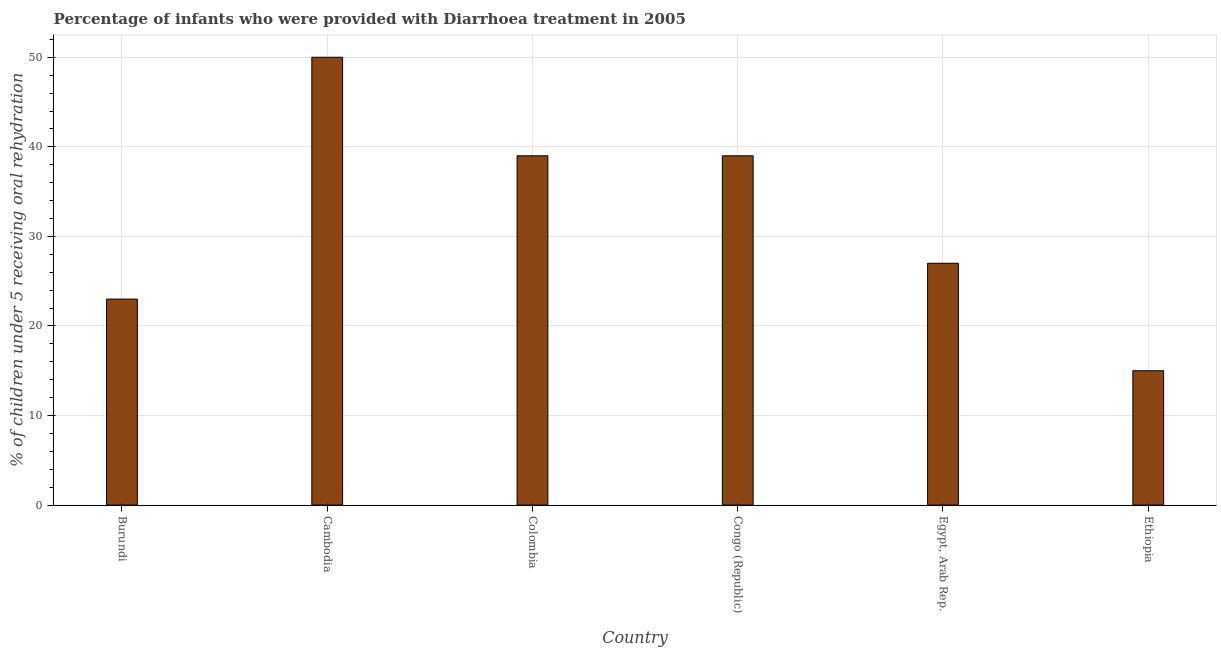Does the graph contain any zero values?
Keep it short and to the point. No. Does the graph contain grids?
Your answer should be very brief. Yes. What is the title of the graph?
Make the answer very short. Percentage of infants who were provided with Diarrhoea treatment in 2005. What is the label or title of the X-axis?
Keep it short and to the point. Country. What is the label or title of the Y-axis?
Ensure brevity in your answer.  % of children under 5 receiving oral rehydration. In which country was the percentage of children who were provided with treatment diarrhoea maximum?
Your answer should be compact. Cambodia. In which country was the percentage of children who were provided with treatment diarrhoea minimum?
Offer a terse response. Ethiopia. What is the sum of the percentage of children who were provided with treatment diarrhoea?
Give a very brief answer. 193. What is the average percentage of children who were provided with treatment diarrhoea per country?
Your answer should be compact. 32.17. What is the ratio of the percentage of children who were provided with treatment diarrhoea in Burundi to that in Ethiopia?
Your answer should be very brief. 1.53. Is the sum of the percentage of children who were provided with treatment diarrhoea in Cambodia and Congo (Republic) greater than the maximum percentage of children who were provided with treatment diarrhoea across all countries?
Offer a terse response. Yes. What is the difference between the highest and the lowest percentage of children who were provided with treatment diarrhoea?
Make the answer very short. 35. How many bars are there?
Provide a short and direct response. 6. Are all the bars in the graph horizontal?
Offer a very short reply. No. How many countries are there in the graph?
Ensure brevity in your answer.  6. What is the difference between two consecutive major ticks on the Y-axis?
Keep it short and to the point. 10. Are the values on the major ticks of Y-axis written in scientific E-notation?
Your response must be concise. No. What is the % of children under 5 receiving oral rehydration of Burundi?
Your response must be concise. 23. What is the % of children under 5 receiving oral rehydration of Cambodia?
Keep it short and to the point. 50. What is the difference between the % of children under 5 receiving oral rehydration in Burundi and Cambodia?
Offer a terse response. -27. What is the difference between the % of children under 5 receiving oral rehydration in Burundi and Colombia?
Provide a short and direct response. -16. What is the difference between the % of children under 5 receiving oral rehydration in Burundi and Congo (Republic)?
Offer a terse response. -16. What is the difference between the % of children under 5 receiving oral rehydration in Burundi and Egypt, Arab Rep.?
Keep it short and to the point. -4. What is the difference between the % of children under 5 receiving oral rehydration in Burundi and Ethiopia?
Make the answer very short. 8. What is the difference between the % of children under 5 receiving oral rehydration in Cambodia and Congo (Republic)?
Provide a short and direct response. 11. What is the difference between the % of children under 5 receiving oral rehydration in Colombia and Egypt, Arab Rep.?
Give a very brief answer. 12. What is the difference between the % of children under 5 receiving oral rehydration in Congo (Republic) and Egypt, Arab Rep.?
Make the answer very short. 12. What is the difference between the % of children under 5 receiving oral rehydration in Congo (Republic) and Ethiopia?
Provide a short and direct response. 24. What is the difference between the % of children under 5 receiving oral rehydration in Egypt, Arab Rep. and Ethiopia?
Keep it short and to the point. 12. What is the ratio of the % of children under 5 receiving oral rehydration in Burundi to that in Cambodia?
Your answer should be very brief. 0.46. What is the ratio of the % of children under 5 receiving oral rehydration in Burundi to that in Colombia?
Your answer should be very brief. 0.59. What is the ratio of the % of children under 5 receiving oral rehydration in Burundi to that in Congo (Republic)?
Offer a very short reply. 0.59. What is the ratio of the % of children under 5 receiving oral rehydration in Burundi to that in Egypt, Arab Rep.?
Provide a succinct answer. 0.85. What is the ratio of the % of children under 5 receiving oral rehydration in Burundi to that in Ethiopia?
Make the answer very short. 1.53. What is the ratio of the % of children under 5 receiving oral rehydration in Cambodia to that in Colombia?
Give a very brief answer. 1.28. What is the ratio of the % of children under 5 receiving oral rehydration in Cambodia to that in Congo (Republic)?
Give a very brief answer. 1.28. What is the ratio of the % of children under 5 receiving oral rehydration in Cambodia to that in Egypt, Arab Rep.?
Make the answer very short. 1.85. What is the ratio of the % of children under 5 receiving oral rehydration in Cambodia to that in Ethiopia?
Your response must be concise. 3.33. What is the ratio of the % of children under 5 receiving oral rehydration in Colombia to that in Egypt, Arab Rep.?
Provide a succinct answer. 1.44. What is the ratio of the % of children under 5 receiving oral rehydration in Congo (Republic) to that in Egypt, Arab Rep.?
Your answer should be compact. 1.44. What is the ratio of the % of children under 5 receiving oral rehydration in Congo (Republic) to that in Ethiopia?
Give a very brief answer. 2.6. 